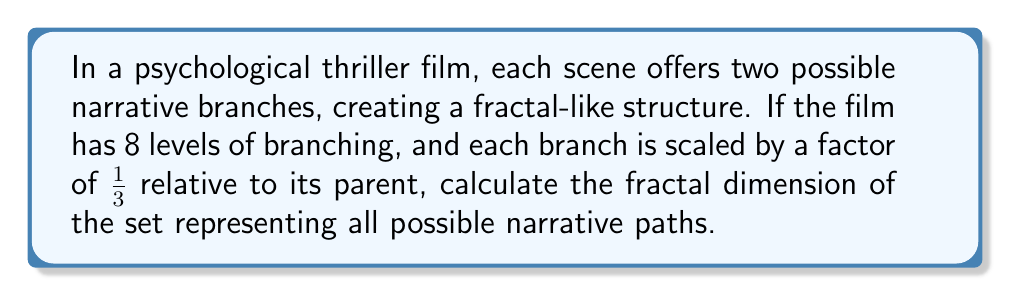Can you solve this math problem? To calculate the fractal dimension of this set, we'll use the box-counting method. Let's approach this step-by-step:

1) In a self-similar fractal, the fractal dimension $D$ is given by the formula:

   $$N = r^{-D}$$

   where $N$ is the number of self-similar pieces and $r$ is the scaling factor.

2) In our case, at each branching level, the number of pieces doubles:
   - Level 1: 2 branches
   - Level 2: 4 branches
   - Level 3: 8 branches
   ...
   - Level 8: $2^8 = 256$ branches

3) The total number of self-similar pieces is thus $N = 2^8 = 256$.

4) The scaling factor is given as $r = 1/3$.

5) Substituting these into our equation:

   $$256 = (1/3)^{-D}$$

6) Taking the logarithm of both sides:

   $$\log 256 = -D \log(1/3)$$

7) Solving for $D$:

   $$D = -\frac{\log 256}{\log(1/3)} = \frac{\log 256}{\log 3}$$

8) Calculating this value:

   $$D \approx 5.6189$$

This fractal dimension indicates that the set of narrative possibilities fills more space than a line (dimension 1) or a plane (dimension 2), but less than a volume (dimension 3), reflecting the complex, branching nature of the thriller's plot structure.
Answer: $\frac{\log 256}{\log 3} \approx 5.6189$ 